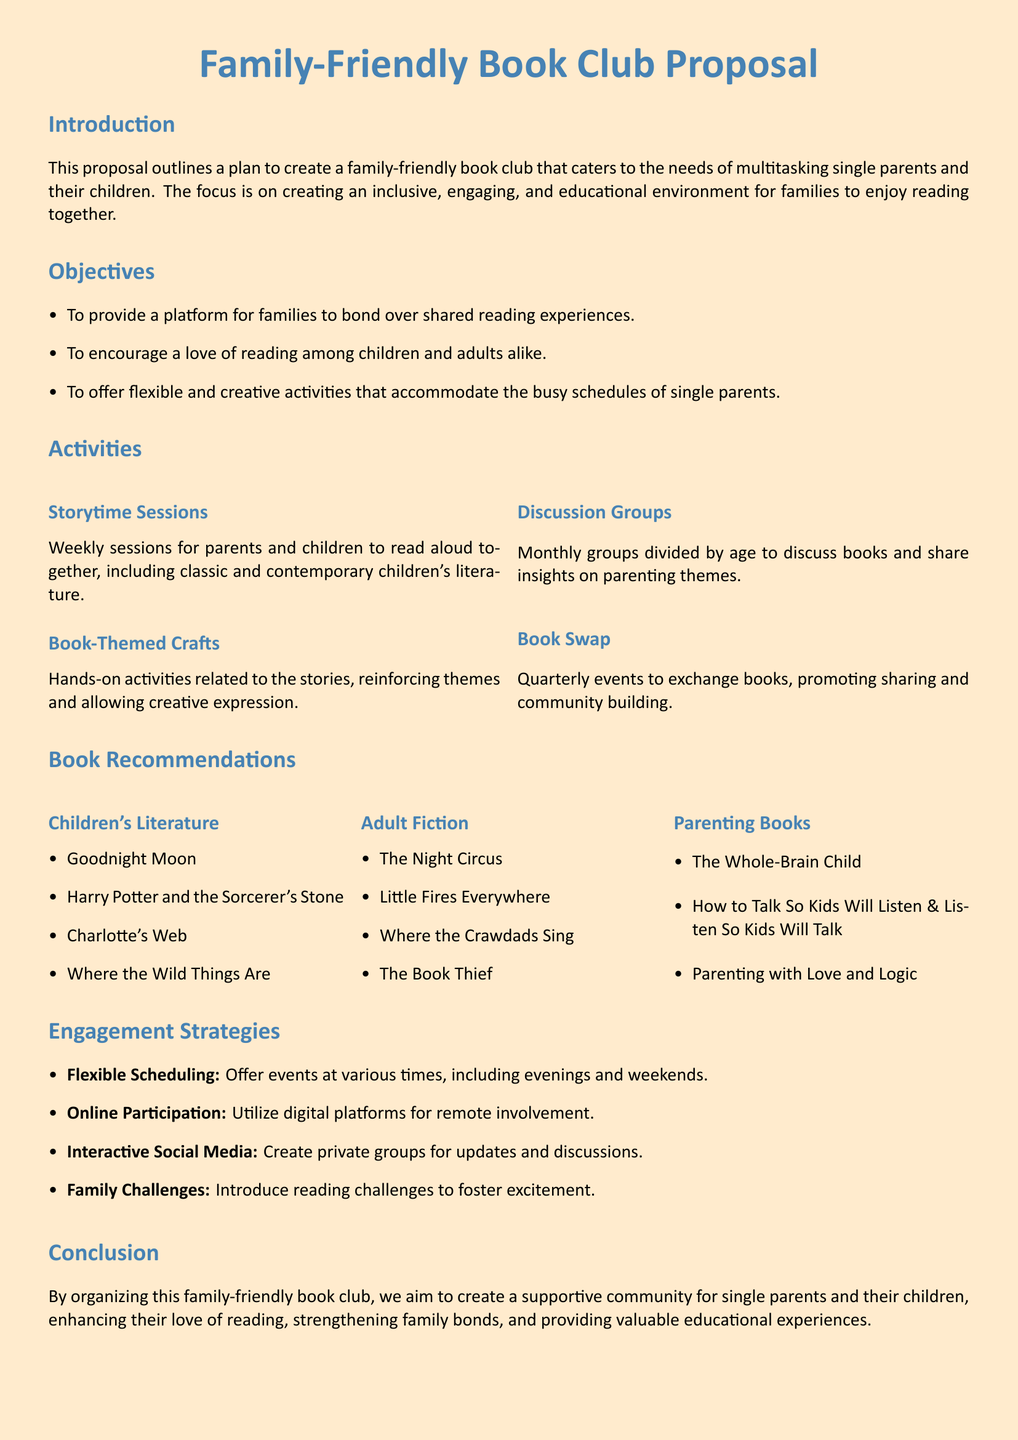What is the main focus of the proposal? The main focus of the proposal is to create an inclusive, engaging, and educational environment for families to enjoy reading together.
Answer: inclusive, engaging, and educational environment How many activities are listed in the proposal? The proposal lists four activities under the Activities section.
Answer: four Name one book recommended for children. The proposal includes several children's books, one of which is Goodnight Moon.
Answer: Goodnight Moon What is one engagement strategy mentioned? The proposal mentions several strategies, including Flexible Scheduling.
Answer: Flexible Scheduling Who is the target audience for the book club? The proposal specifies that the target audience is multitasking single parents and their children.
Answer: multitasking single parents and their children What type of books are included in the Parenting Books section? This section includes titles that focus on parenting strategies and advice.
Answer: parenting strategies and advice What is the purpose of the Book Swap activity? The purpose of the Book Swap activity is to promote sharing and community building.
Answer: promote sharing and community building When will storytime sessions take place? The frequency of storytime sessions is weekly, according to the proposal.
Answer: weekly 